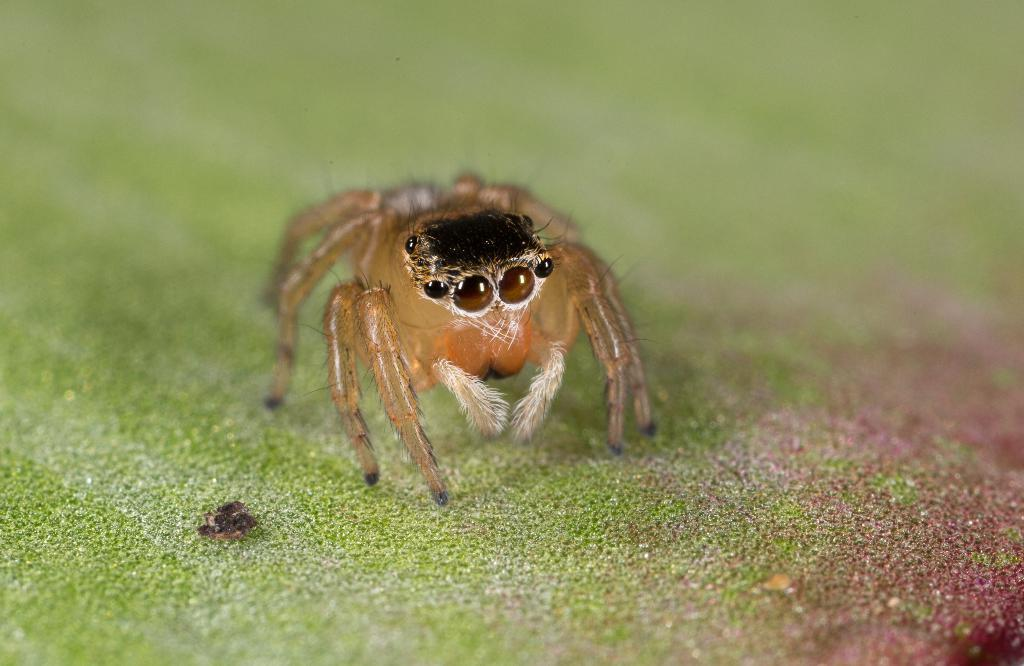What type of creature can be seen in the image? There is an insect in the image. Can you describe the background of the image? The background of the image is blurred. What month is depicted in the image? There is no indication of a specific month in the image, as it only features an insect and a blurred background. 